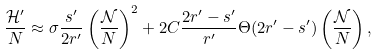Convert formula to latex. <formula><loc_0><loc_0><loc_500><loc_500>\frac { \mathcal { H } ^ { \prime } } { N } \approx \sigma \frac { s ^ { \prime } } { 2 r ^ { \prime } } \left ( \frac { \mathcal { N } } { N } \right ) ^ { 2 } + 2 C \frac { 2 r ^ { \prime } - s ^ { \prime } } { r ^ { \prime } } \Theta ( 2 r ^ { \prime } - s ^ { \prime } ) \left ( \frac { \mathcal { N } } { N } \right ) ,</formula> 